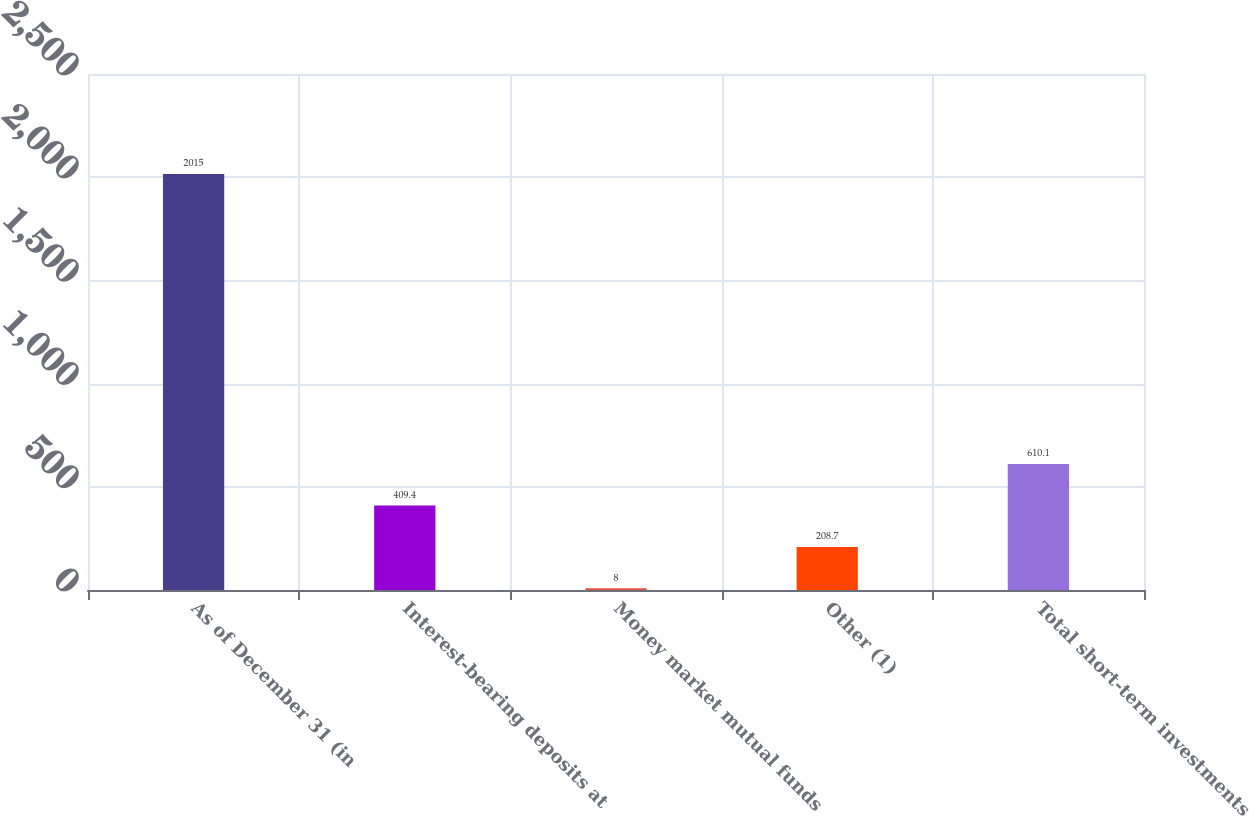<chart> <loc_0><loc_0><loc_500><loc_500><bar_chart><fcel>As of December 31 (in<fcel>Interest-bearing deposits at<fcel>Money market mutual funds<fcel>Other (1)<fcel>Total short-term investments<nl><fcel>2015<fcel>409.4<fcel>8<fcel>208.7<fcel>610.1<nl></chart> 